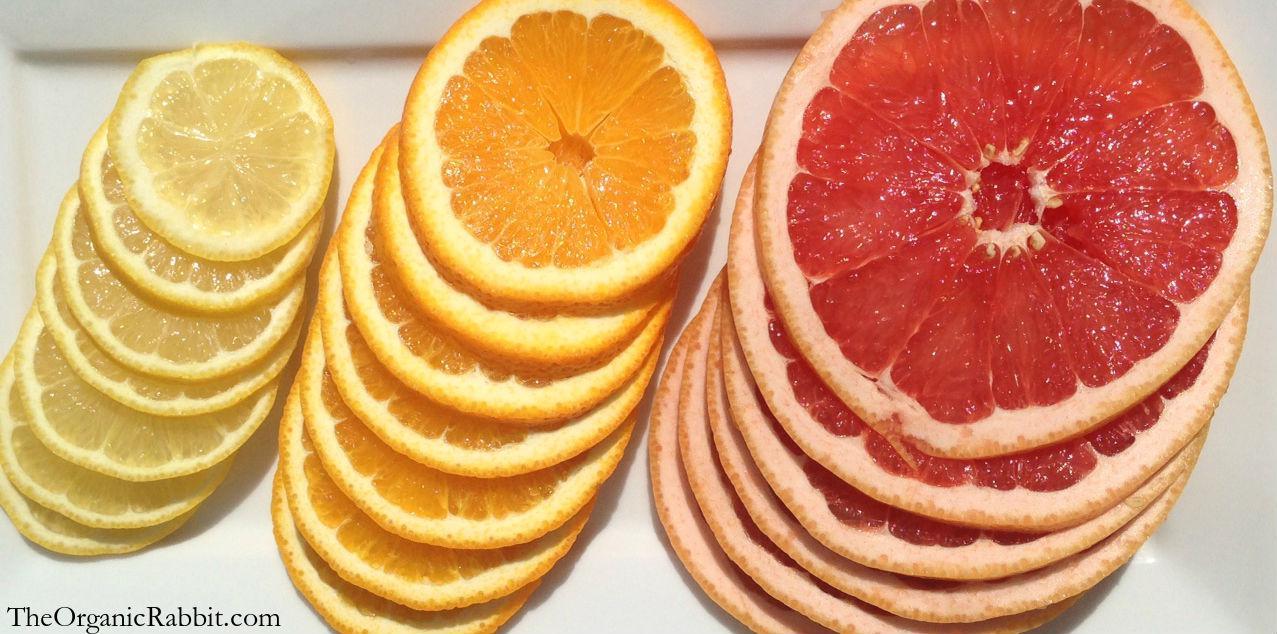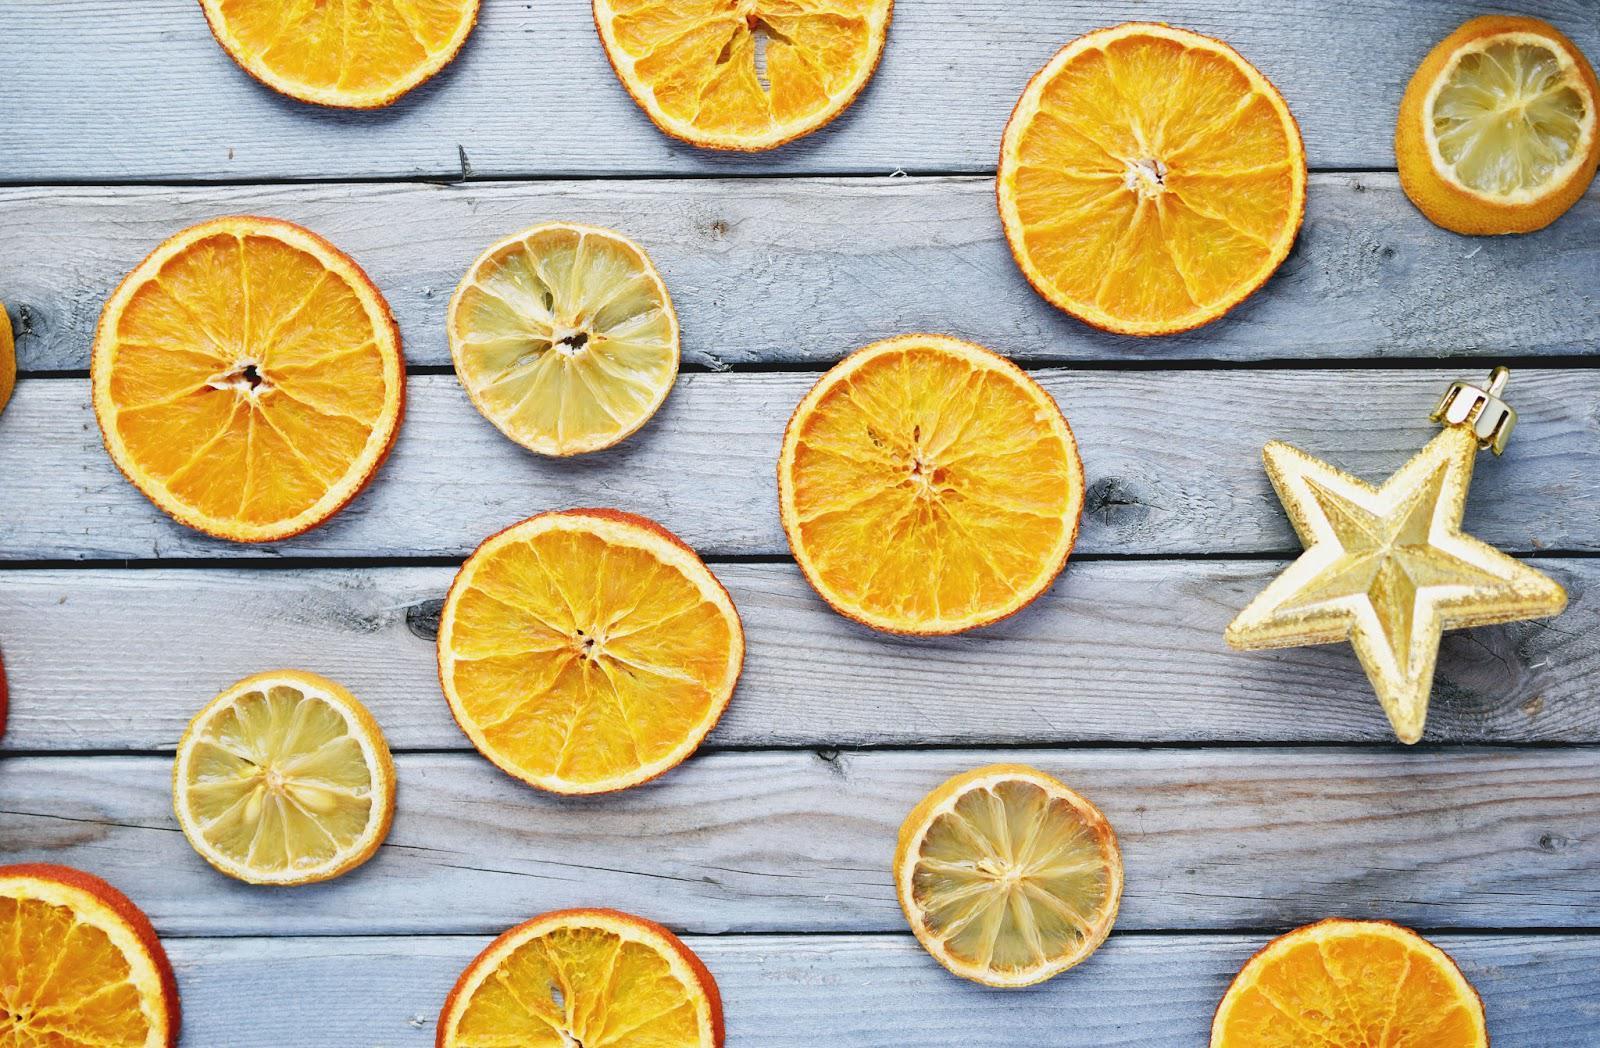The first image is the image on the left, the second image is the image on the right. Evaluate the accuracy of this statement regarding the images: "Some of the lemons are not sliced.". Is it true? Answer yes or no. No. The first image is the image on the left, the second image is the image on the right. Given the left and right images, does the statement "There are dried sliced oranges in a back bowl on a wooden table, there is a tea cup next to the bowl" hold true? Answer yes or no. No. 